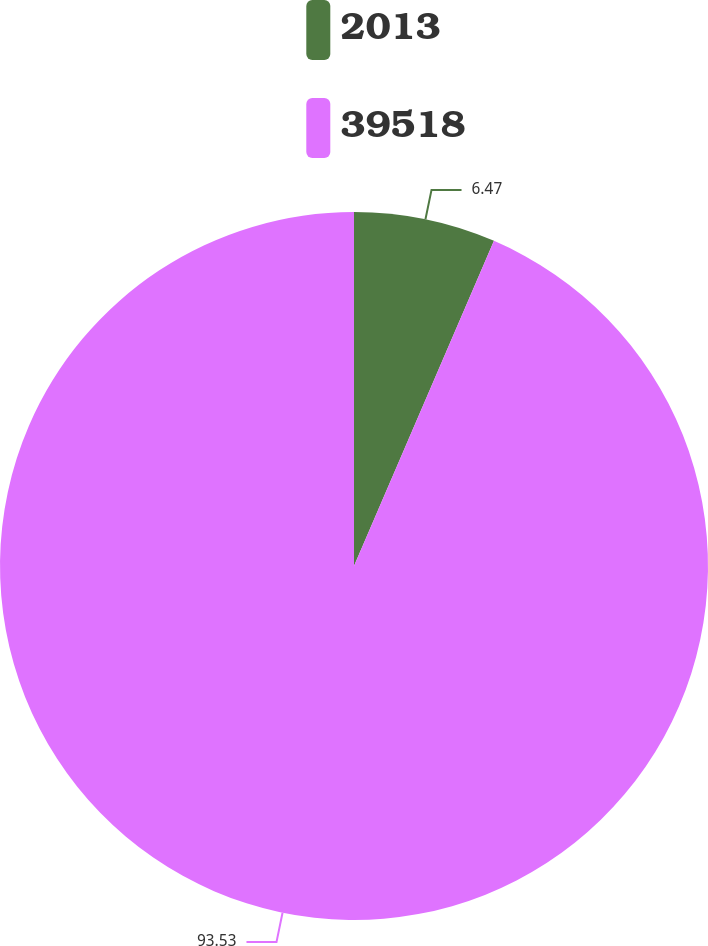<chart> <loc_0><loc_0><loc_500><loc_500><pie_chart><fcel>2013<fcel>39518<nl><fcel>6.47%<fcel>93.53%<nl></chart> 